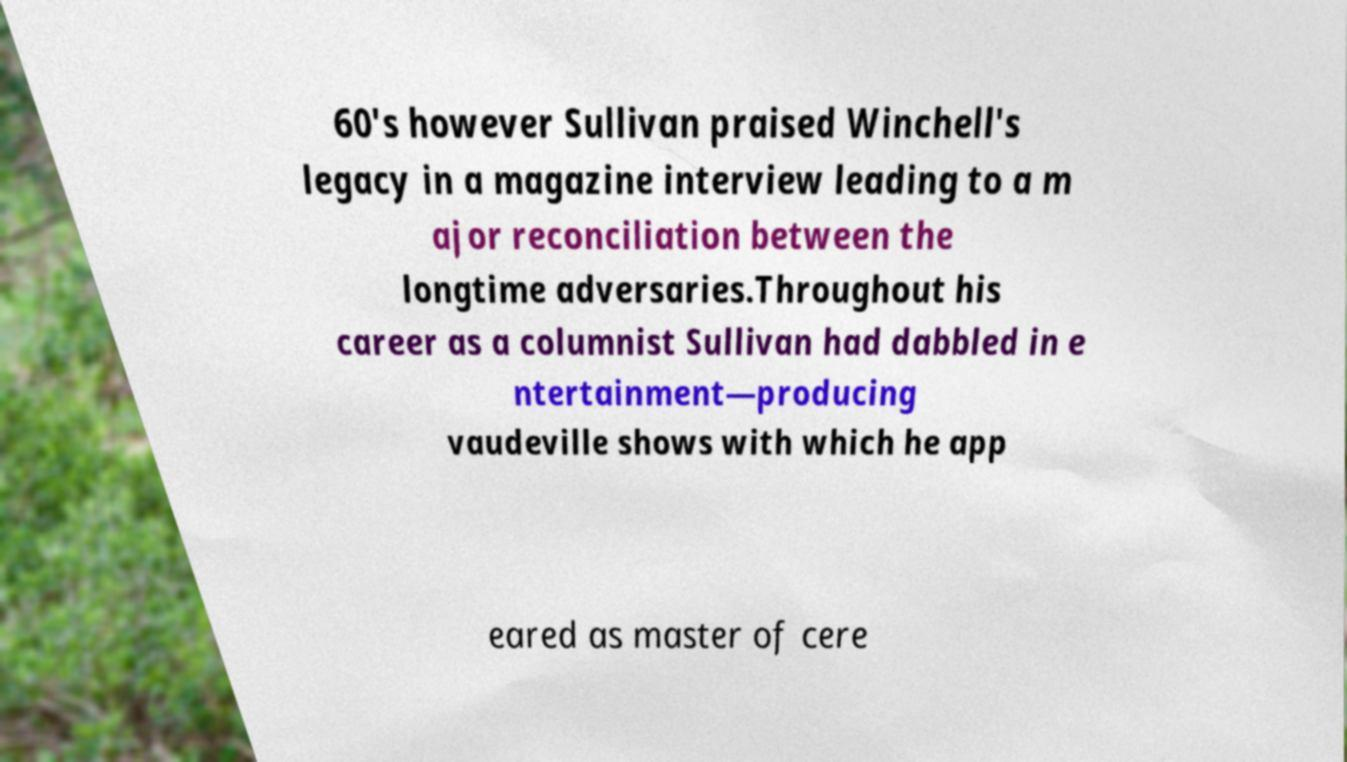Could you assist in decoding the text presented in this image and type it out clearly? 60's however Sullivan praised Winchell's legacy in a magazine interview leading to a m ajor reconciliation between the longtime adversaries.Throughout his career as a columnist Sullivan had dabbled in e ntertainment—producing vaudeville shows with which he app eared as master of cere 